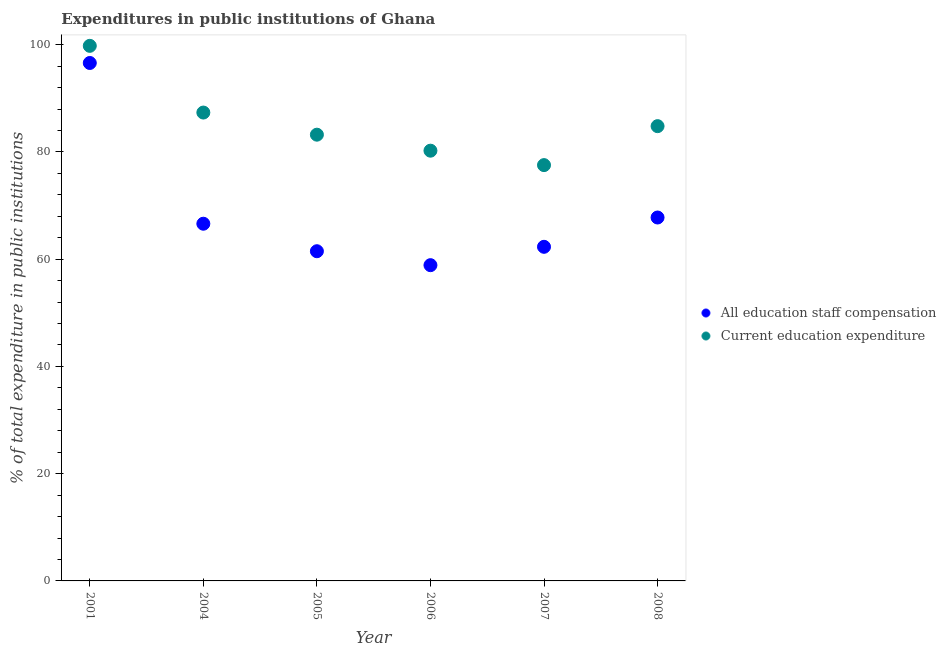How many different coloured dotlines are there?
Make the answer very short. 2. What is the expenditure in education in 2004?
Your response must be concise. 87.35. Across all years, what is the maximum expenditure in staff compensation?
Offer a terse response. 96.59. Across all years, what is the minimum expenditure in staff compensation?
Provide a short and direct response. 58.88. In which year was the expenditure in education minimum?
Make the answer very short. 2007. What is the total expenditure in education in the graph?
Offer a terse response. 512.94. What is the difference between the expenditure in education in 2005 and that in 2008?
Your answer should be compact. -1.59. What is the difference between the expenditure in education in 2007 and the expenditure in staff compensation in 2005?
Give a very brief answer. 16.06. What is the average expenditure in staff compensation per year?
Provide a short and direct response. 68.94. In the year 2005, what is the difference between the expenditure in education and expenditure in staff compensation?
Provide a short and direct response. 21.73. What is the ratio of the expenditure in education in 2001 to that in 2005?
Your answer should be very brief. 1.2. Is the expenditure in staff compensation in 2006 less than that in 2007?
Provide a succinct answer. Yes. What is the difference between the highest and the second highest expenditure in staff compensation?
Your answer should be very brief. 28.82. What is the difference between the highest and the lowest expenditure in education?
Give a very brief answer. 22.24. In how many years, is the expenditure in staff compensation greater than the average expenditure in staff compensation taken over all years?
Provide a short and direct response. 1. Is the sum of the expenditure in education in 2001 and 2007 greater than the maximum expenditure in staff compensation across all years?
Make the answer very short. Yes. Is the expenditure in staff compensation strictly greater than the expenditure in education over the years?
Keep it short and to the point. No. How many dotlines are there?
Make the answer very short. 2. Does the graph contain any zero values?
Ensure brevity in your answer.  No. Where does the legend appear in the graph?
Keep it short and to the point. Center right. What is the title of the graph?
Your response must be concise. Expenditures in public institutions of Ghana. Does "Girls" appear as one of the legend labels in the graph?
Your response must be concise. No. What is the label or title of the Y-axis?
Keep it short and to the point. % of total expenditure in public institutions. What is the % of total expenditure in public institutions of All education staff compensation in 2001?
Offer a very short reply. 96.59. What is the % of total expenditure in public institutions of Current education expenditure in 2001?
Your response must be concise. 99.79. What is the % of total expenditure in public institutions in All education staff compensation in 2004?
Your response must be concise. 66.61. What is the % of total expenditure in public institutions in Current education expenditure in 2004?
Provide a succinct answer. 87.35. What is the % of total expenditure in public institutions of All education staff compensation in 2005?
Give a very brief answer. 61.49. What is the % of total expenditure in public institutions in Current education expenditure in 2005?
Provide a short and direct response. 83.22. What is the % of total expenditure in public institutions in All education staff compensation in 2006?
Offer a terse response. 58.88. What is the % of total expenditure in public institutions of Current education expenditure in 2006?
Your response must be concise. 80.23. What is the % of total expenditure in public institutions in All education staff compensation in 2007?
Offer a terse response. 62.31. What is the % of total expenditure in public institutions of Current education expenditure in 2007?
Offer a terse response. 77.54. What is the % of total expenditure in public institutions in All education staff compensation in 2008?
Offer a very short reply. 67.77. What is the % of total expenditure in public institutions of Current education expenditure in 2008?
Provide a short and direct response. 84.81. Across all years, what is the maximum % of total expenditure in public institutions of All education staff compensation?
Ensure brevity in your answer.  96.59. Across all years, what is the maximum % of total expenditure in public institutions of Current education expenditure?
Your answer should be very brief. 99.79. Across all years, what is the minimum % of total expenditure in public institutions in All education staff compensation?
Offer a terse response. 58.88. Across all years, what is the minimum % of total expenditure in public institutions in Current education expenditure?
Provide a short and direct response. 77.54. What is the total % of total expenditure in public institutions in All education staff compensation in the graph?
Your response must be concise. 413.66. What is the total % of total expenditure in public institutions in Current education expenditure in the graph?
Keep it short and to the point. 512.94. What is the difference between the % of total expenditure in public institutions of All education staff compensation in 2001 and that in 2004?
Provide a succinct answer. 29.98. What is the difference between the % of total expenditure in public institutions in Current education expenditure in 2001 and that in 2004?
Offer a very short reply. 12.44. What is the difference between the % of total expenditure in public institutions in All education staff compensation in 2001 and that in 2005?
Make the answer very short. 35.11. What is the difference between the % of total expenditure in public institutions of Current education expenditure in 2001 and that in 2005?
Offer a terse response. 16.57. What is the difference between the % of total expenditure in public institutions of All education staff compensation in 2001 and that in 2006?
Offer a terse response. 37.71. What is the difference between the % of total expenditure in public institutions of Current education expenditure in 2001 and that in 2006?
Make the answer very short. 19.55. What is the difference between the % of total expenditure in public institutions in All education staff compensation in 2001 and that in 2007?
Provide a succinct answer. 34.28. What is the difference between the % of total expenditure in public institutions in Current education expenditure in 2001 and that in 2007?
Offer a very short reply. 22.24. What is the difference between the % of total expenditure in public institutions of All education staff compensation in 2001 and that in 2008?
Your response must be concise. 28.82. What is the difference between the % of total expenditure in public institutions of Current education expenditure in 2001 and that in 2008?
Make the answer very short. 14.98. What is the difference between the % of total expenditure in public institutions of All education staff compensation in 2004 and that in 2005?
Give a very brief answer. 5.13. What is the difference between the % of total expenditure in public institutions in Current education expenditure in 2004 and that in 2005?
Your answer should be compact. 4.13. What is the difference between the % of total expenditure in public institutions of All education staff compensation in 2004 and that in 2006?
Your response must be concise. 7.73. What is the difference between the % of total expenditure in public institutions of Current education expenditure in 2004 and that in 2006?
Provide a short and direct response. 7.11. What is the difference between the % of total expenditure in public institutions of All education staff compensation in 2004 and that in 2007?
Your response must be concise. 4.31. What is the difference between the % of total expenditure in public institutions of Current education expenditure in 2004 and that in 2007?
Your answer should be very brief. 9.8. What is the difference between the % of total expenditure in public institutions in All education staff compensation in 2004 and that in 2008?
Ensure brevity in your answer.  -1.16. What is the difference between the % of total expenditure in public institutions in Current education expenditure in 2004 and that in 2008?
Offer a very short reply. 2.54. What is the difference between the % of total expenditure in public institutions of All education staff compensation in 2005 and that in 2006?
Provide a succinct answer. 2.6. What is the difference between the % of total expenditure in public institutions in Current education expenditure in 2005 and that in 2006?
Your response must be concise. 2.98. What is the difference between the % of total expenditure in public institutions in All education staff compensation in 2005 and that in 2007?
Offer a very short reply. -0.82. What is the difference between the % of total expenditure in public institutions of Current education expenditure in 2005 and that in 2007?
Ensure brevity in your answer.  5.68. What is the difference between the % of total expenditure in public institutions of All education staff compensation in 2005 and that in 2008?
Your answer should be compact. -6.29. What is the difference between the % of total expenditure in public institutions of Current education expenditure in 2005 and that in 2008?
Your answer should be compact. -1.59. What is the difference between the % of total expenditure in public institutions of All education staff compensation in 2006 and that in 2007?
Give a very brief answer. -3.42. What is the difference between the % of total expenditure in public institutions of Current education expenditure in 2006 and that in 2007?
Offer a very short reply. 2.69. What is the difference between the % of total expenditure in public institutions in All education staff compensation in 2006 and that in 2008?
Ensure brevity in your answer.  -8.89. What is the difference between the % of total expenditure in public institutions of Current education expenditure in 2006 and that in 2008?
Provide a succinct answer. -4.58. What is the difference between the % of total expenditure in public institutions of All education staff compensation in 2007 and that in 2008?
Your response must be concise. -5.46. What is the difference between the % of total expenditure in public institutions in Current education expenditure in 2007 and that in 2008?
Keep it short and to the point. -7.27. What is the difference between the % of total expenditure in public institutions in All education staff compensation in 2001 and the % of total expenditure in public institutions in Current education expenditure in 2004?
Your answer should be compact. 9.25. What is the difference between the % of total expenditure in public institutions in All education staff compensation in 2001 and the % of total expenditure in public institutions in Current education expenditure in 2005?
Provide a succinct answer. 13.37. What is the difference between the % of total expenditure in public institutions in All education staff compensation in 2001 and the % of total expenditure in public institutions in Current education expenditure in 2006?
Keep it short and to the point. 16.36. What is the difference between the % of total expenditure in public institutions of All education staff compensation in 2001 and the % of total expenditure in public institutions of Current education expenditure in 2007?
Offer a terse response. 19.05. What is the difference between the % of total expenditure in public institutions of All education staff compensation in 2001 and the % of total expenditure in public institutions of Current education expenditure in 2008?
Ensure brevity in your answer.  11.78. What is the difference between the % of total expenditure in public institutions of All education staff compensation in 2004 and the % of total expenditure in public institutions of Current education expenditure in 2005?
Keep it short and to the point. -16.61. What is the difference between the % of total expenditure in public institutions in All education staff compensation in 2004 and the % of total expenditure in public institutions in Current education expenditure in 2006?
Keep it short and to the point. -13.62. What is the difference between the % of total expenditure in public institutions in All education staff compensation in 2004 and the % of total expenditure in public institutions in Current education expenditure in 2007?
Your response must be concise. -10.93. What is the difference between the % of total expenditure in public institutions of All education staff compensation in 2004 and the % of total expenditure in public institutions of Current education expenditure in 2008?
Your response must be concise. -18.2. What is the difference between the % of total expenditure in public institutions of All education staff compensation in 2005 and the % of total expenditure in public institutions of Current education expenditure in 2006?
Provide a short and direct response. -18.75. What is the difference between the % of total expenditure in public institutions in All education staff compensation in 2005 and the % of total expenditure in public institutions in Current education expenditure in 2007?
Make the answer very short. -16.06. What is the difference between the % of total expenditure in public institutions in All education staff compensation in 2005 and the % of total expenditure in public institutions in Current education expenditure in 2008?
Offer a terse response. -23.32. What is the difference between the % of total expenditure in public institutions in All education staff compensation in 2006 and the % of total expenditure in public institutions in Current education expenditure in 2007?
Your answer should be compact. -18.66. What is the difference between the % of total expenditure in public institutions in All education staff compensation in 2006 and the % of total expenditure in public institutions in Current education expenditure in 2008?
Give a very brief answer. -25.93. What is the difference between the % of total expenditure in public institutions of All education staff compensation in 2007 and the % of total expenditure in public institutions of Current education expenditure in 2008?
Make the answer very short. -22.5. What is the average % of total expenditure in public institutions of All education staff compensation per year?
Give a very brief answer. 68.94. What is the average % of total expenditure in public institutions of Current education expenditure per year?
Ensure brevity in your answer.  85.49. In the year 2001, what is the difference between the % of total expenditure in public institutions in All education staff compensation and % of total expenditure in public institutions in Current education expenditure?
Keep it short and to the point. -3.2. In the year 2004, what is the difference between the % of total expenditure in public institutions of All education staff compensation and % of total expenditure in public institutions of Current education expenditure?
Offer a terse response. -20.73. In the year 2005, what is the difference between the % of total expenditure in public institutions in All education staff compensation and % of total expenditure in public institutions in Current education expenditure?
Provide a short and direct response. -21.73. In the year 2006, what is the difference between the % of total expenditure in public institutions in All education staff compensation and % of total expenditure in public institutions in Current education expenditure?
Offer a terse response. -21.35. In the year 2007, what is the difference between the % of total expenditure in public institutions of All education staff compensation and % of total expenditure in public institutions of Current education expenditure?
Provide a succinct answer. -15.24. In the year 2008, what is the difference between the % of total expenditure in public institutions in All education staff compensation and % of total expenditure in public institutions in Current education expenditure?
Offer a terse response. -17.04. What is the ratio of the % of total expenditure in public institutions of All education staff compensation in 2001 to that in 2004?
Keep it short and to the point. 1.45. What is the ratio of the % of total expenditure in public institutions in Current education expenditure in 2001 to that in 2004?
Offer a very short reply. 1.14. What is the ratio of the % of total expenditure in public institutions in All education staff compensation in 2001 to that in 2005?
Your answer should be compact. 1.57. What is the ratio of the % of total expenditure in public institutions in Current education expenditure in 2001 to that in 2005?
Offer a terse response. 1.2. What is the ratio of the % of total expenditure in public institutions of All education staff compensation in 2001 to that in 2006?
Your answer should be compact. 1.64. What is the ratio of the % of total expenditure in public institutions in Current education expenditure in 2001 to that in 2006?
Offer a very short reply. 1.24. What is the ratio of the % of total expenditure in public institutions in All education staff compensation in 2001 to that in 2007?
Provide a succinct answer. 1.55. What is the ratio of the % of total expenditure in public institutions of Current education expenditure in 2001 to that in 2007?
Your answer should be very brief. 1.29. What is the ratio of the % of total expenditure in public institutions in All education staff compensation in 2001 to that in 2008?
Make the answer very short. 1.43. What is the ratio of the % of total expenditure in public institutions in Current education expenditure in 2001 to that in 2008?
Offer a very short reply. 1.18. What is the ratio of the % of total expenditure in public institutions of All education staff compensation in 2004 to that in 2005?
Give a very brief answer. 1.08. What is the ratio of the % of total expenditure in public institutions of Current education expenditure in 2004 to that in 2005?
Your answer should be very brief. 1.05. What is the ratio of the % of total expenditure in public institutions in All education staff compensation in 2004 to that in 2006?
Your answer should be compact. 1.13. What is the ratio of the % of total expenditure in public institutions in Current education expenditure in 2004 to that in 2006?
Ensure brevity in your answer.  1.09. What is the ratio of the % of total expenditure in public institutions in All education staff compensation in 2004 to that in 2007?
Provide a succinct answer. 1.07. What is the ratio of the % of total expenditure in public institutions of Current education expenditure in 2004 to that in 2007?
Your answer should be very brief. 1.13. What is the ratio of the % of total expenditure in public institutions in All education staff compensation in 2004 to that in 2008?
Provide a short and direct response. 0.98. What is the ratio of the % of total expenditure in public institutions of Current education expenditure in 2004 to that in 2008?
Keep it short and to the point. 1.03. What is the ratio of the % of total expenditure in public institutions in All education staff compensation in 2005 to that in 2006?
Keep it short and to the point. 1.04. What is the ratio of the % of total expenditure in public institutions in Current education expenditure in 2005 to that in 2006?
Offer a very short reply. 1.04. What is the ratio of the % of total expenditure in public institutions in All education staff compensation in 2005 to that in 2007?
Your answer should be compact. 0.99. What is the ratio of the % of total expenditure in public institutions of Current education expenditure in 2005 to that in 2007?
Your response must be concise. 1.07. What is the ratio of the % of total expenditure in public institutions in All education staff compensation in 2005 to that in 2008?
Keep it short and to the point. 0.91. What is the ratio of the % of total expenditure in public institutions of Current education expenditure in 2005 to that in 2008?
Provide a short and direct response. 0.98. What is the ratio of the % of total expenditure in public institutions of All education staff compensation in 2006 to that in 2007?
Offer a very short reply. 0.95. What is the ratio of the % of total expenditure in public institutions in Current education expenditure in 2006 to that in 2007?
Offer a terse response. 1.03. What is the ratio of the % of total expenditure in public institutions of All education staff compensation in 2006 to that in 2008?
Keep it short and to the point. 0.87. What is the ratio of the % of total expenditure in public institutions in Current education expenditure in 2006 to that in 2008?
Give a very brief answer. 0.95. What is the ratio of the % of total expenditure in public institutions of All education staff compensation in 2007 to that in 2008?
Your answer should be compact. 0.92. What is the ratio of the % of total expenditure in public institutions of Current education expenditure in 2007 to that in 2008?
Provide a succinct answer. 0.91. What is the difference between the highest and the second highest % of total expenditure in public institutions of All education staff compensation?
Offer a very short reply. 28.82. What is the difference between the highest and the second highest % of total expenditure in public institutions in Current education expenditure?
Your answer should be compact. 12.44. What is the difference between the highest and the lowest % of total expenditure in public institutions of All education staff compensation?
Make the answer very short. 37.71. What is the difference between the highest and the lowest % of total expenditure in public institutions in Current education expenditure?
Your response must be concise. 22.24. 